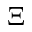<formula> <loc_0><loc_0><loc_500><loc_500>\Xi</formula> 